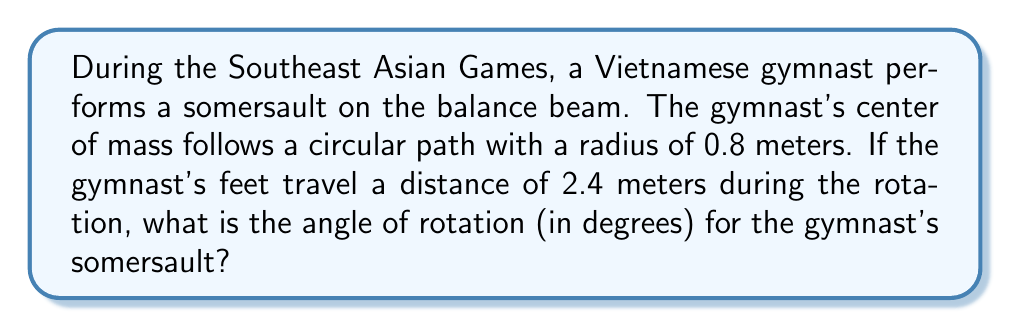Can you answer this question? To solve this problem, we'll use the relationship between arc length, radius, and central angle in a circle. Let's break it down step-by-step:

1) The formula for arc length is:
   $s = r\theta$
   Where:
   $s$ = arc length
   $r$ = radius
   $\theta$ = angle in radians

2) We're given:
   $s = 2.4$ meters (distance traveled by feet)
   $r = 0.8$ meters (radius of circular path)

3) Substituting these values into the formula:
   $2.4 = 0.8\theta$

4) Solving for $\theta$:
   $$\theta = \frac{2.4}{0.8} = 3 \text{ radians}$$

5) However, the question asks for the angle in degrees. To convert from radians to degrees, we use the formula:
   $$\text{degrees} = \frac{180^\circ}{\pi} \cdot \text{radians}$$

6) Substituting our value of 3 radians:
   $$\text{degrees} = \frac{180^\circ}{\pi} \cdot 3 = \frac{540^\circ}{\pi} \approx 171.89^\circ$$

Therefore, the angle of rotation for the gymnast's somersault is approximately 171.89 degrees.
Answer: $171.89^\circ$ (rounded to two decimal places) 